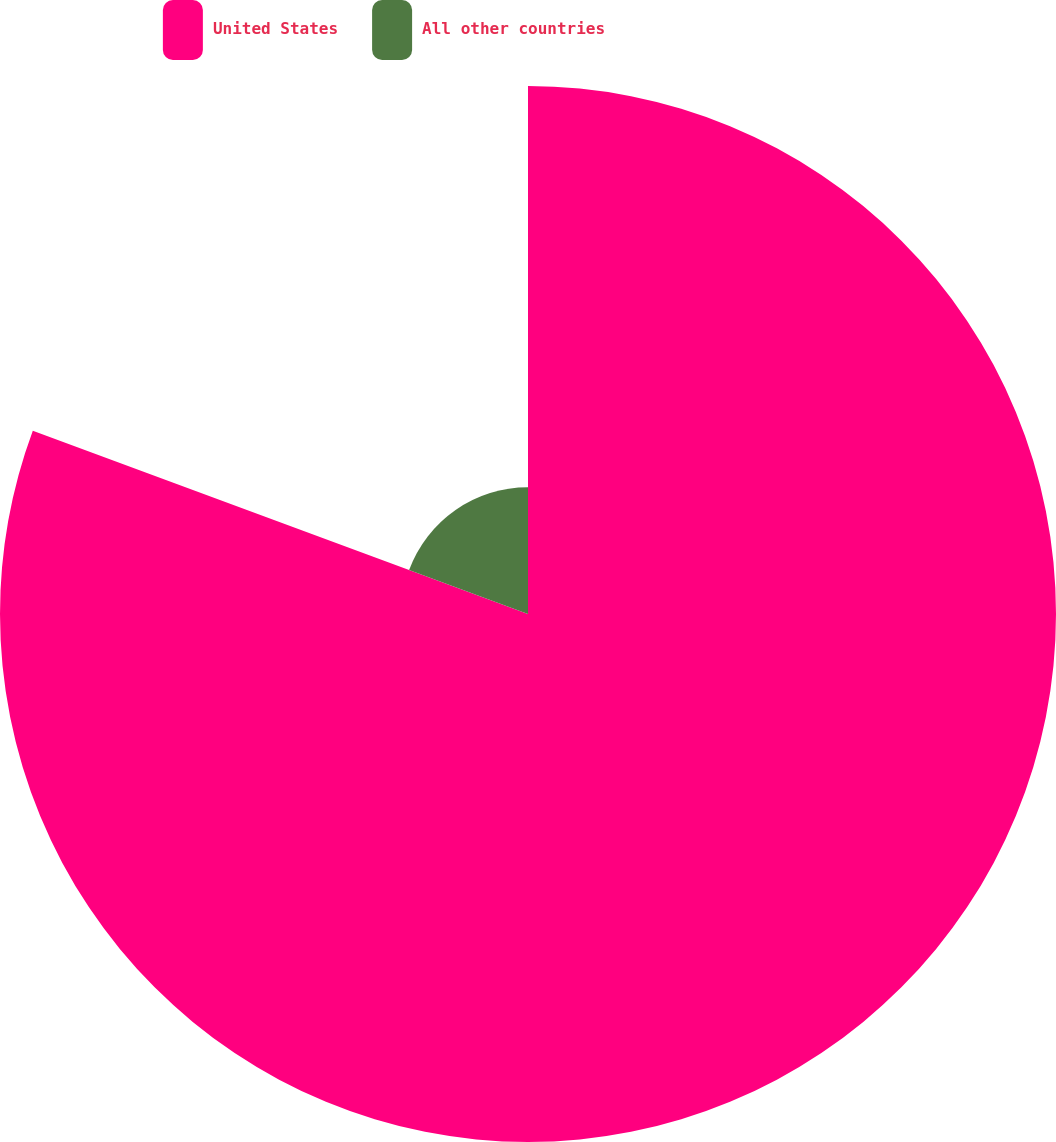Convert chart to OTSL. <chart><loc_0><loc_0><loc_500><loc_500><pie_chart><fcel>United States<fcel>All other countries<nl><fcel>80.64%<fcel>19.36%<nl></chart> 